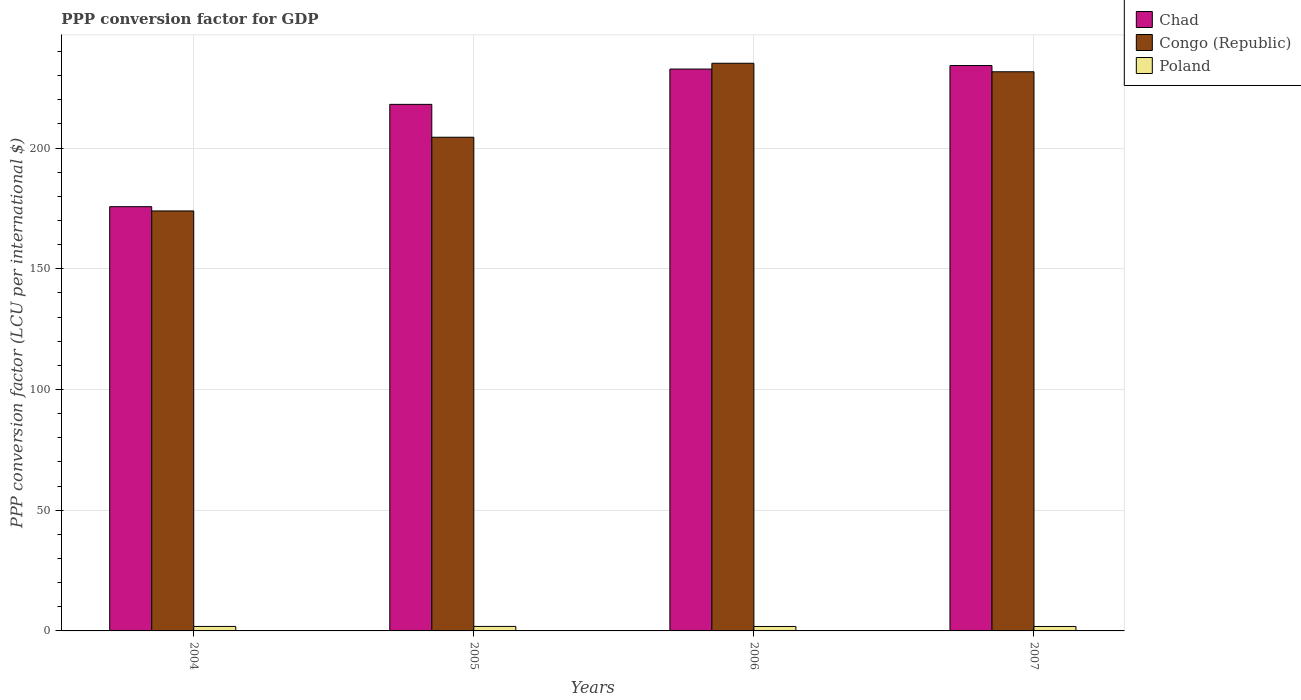How many different coloured bars are there?
Your answer should be compact. 3. How many bars are there on the 3rd tick from the right?
Give a very brief answer. 3. What is the label of the 4th group of bars from the left?
Provide a short and direct response. 2007. In how many cases, is the number of bars for a given year not equal to the number of legend labels?
Your answer should be compact. 0. What is the PPP conversion factor for GDP in Poland in 2006?
Keep it short and to the point. 1.84. Across all years, what is the maximum PPP conversion factor for GDP in Congo (Republic)?
Your response must be concise. 235.12. Across all years, what is the minimum PPP conversion factor for GDP in Poland?
Provide a short and direct response. 1.84. In which year was the PPP conversion factor for GDP in Poland maximum?
Give a very brief answer. 2005. In which year was the PPP conversion factor for GDP in Chad minimum?
Offer a very short reply. 2004. What is the total PPP conversion factor for GDP in Poland in the graph?
Make the answer very short. 7.42. What is the difference between the PPP conversion factor for GDP in Poland in 2004 and that in 2005?
Provide a short and direct response. -0.01. What is the difference between the PPP conversion factor for GDP in Chad in 2005 and the PPP conversion factor for GDP in Congo (Republic) in 2004?
Make the answer very short. 44.14. What is the average PPP conversion factor for GDP in Congo (Republic) per year?
Offer a terse response. 211.28. In the year 2004, what is the difference between the PPP conversion factor for GDP in Chad and PPP conversion factor for GDP in Congo (Republic)?
Ensure brevity in your answer.  1.76. What is the ratio of the PPP conversion factor for GDP in Poland in 2005 to that in 2007?
Offer a very short reply. 1.01. Is the PPP conversion factor for GDP in Poland in 2004 less than that in 2005?
Provide a succinct answer. Yes. Is the difference between the PPP conversion factor for GDP in Chad in 2004 and 2006 greater than the difference between the PPP conversion factor for GDP in Congo (Republic) in 2004 and 2006?
Give a very brief answer. Yes. What is the difference between the highest and the second highest PPP conversion factor for GDP in Chad?
Your response must be concise. 1.45. What is the difference between the highest and the lowest PPP conversion factor for GDP in Congo (Republic)?
Offer a very short reply. 61.17. Is the sum of the PPP conversion factor for GDP in Congo (Republic) in 2006 and 2007 greater than the maximum PPP conversion factor for GDP in Chad across all years?
Your response must be concise. Yes. What does the 1st bar from the left in 2007 represents?
Give a very brief answer. Chad. What does the 1st bar from the right in 2007 represents?
Ensure brevity in your answer.  Poland. Is it the case that in every year, the sum of the PPP conversion factor for GDP in Poland and PPP conversion factor for GDP in Congo (Republic) is greater than the PPP conversion factor for GDP in Chad?
Offer a terse response. No. What is the difference between two consecutive major ticks on the Y-axis?
Offer a very short reply. 50. Does the graph contain any zero values?
Make the answer very short. No. What is the title of the graph?
Offer a very short reply. PPP conversion factor for GDP. What is the label or title of the X-axis?
Ensure brevity in your answer.  Years. What is the label or title of the Y-axis?
Provide a succinct answer. PPP conversion factor (LCU per international $). What is the PPP conversion factor (LCU per international $) of Chad in 2004?
Provide a short and direct response. 175.71. What is the PPP conversion factor (LCU per international $) in Congo (Republic) in 2004?
Provide a short and direct response. 173.95. What is the PPP conversion factor (LCU per international $) of Poland in 2004?
Offer a terse response. 1.86. What is the PPP conversion factor (LCU per international $) in Chad in 2005?
Keep it short and to the point. 218.09. What is the PPP conversion factor (LCU per international $) of Congo (Republic) in 2005?
Provide a succinct answer. 204.47. What is the PPP conversion factor (LCU per international $) in Poland in 2005?
Offer a terse response. 1.87. What is the PPP conversion factor (LCU per international $) in Chad in 2006?
Provide a succinct answer. 232.72. What is the PPP conversion factor (LCU per international $) in Congo (Republic) in 2006?
Provide a short and direct response. 235.12. What is the PPP conversion factor (LCU per international $) in Poland in 2006?
Your answer should be compact. 1.84. What is the PPP conversion factor (LCU per international $) of Chad in 2007?
Provide a short and direct response. 234.17. What is the PPP conversion factor (LCU per international $) in Congo (Republic) in 2007?
Keep it short and to the point. 231.59. What is the PPP conversion factor (LCU per international $) of Poland in 2007?
Provide a short and direct response. 1.84. Across all years, what is the maximum PPP conversion factor (LCU per international $) in Chad?
Ensure brevity in your answer.  234.17. Across all years, what is the maximum PPP conversion factor (LCU per international $) in Congo (Republic)?
Your answer should be very brief. 235.12. Across all years, what is the maximum PPP conversion factor (LCU per international $) in Poland?
Provide a short and direct response. 1.87. Across all years, what is the minimum PPP conversion factor (LCU per international $) of Chad?
Keep it short and to the point. 175.71. Across all years, what is the minimum PPP conversion factor (LCU per international $) in Congo (Republic)?
Make the answer very short. 173.95. Across all years, what is the minimum PPP conversion factor (LCU per international $) in Poland?
Provide a short and direct response. 1.84. What is the total PPP conversion factor (LCU per international $) in Chad in the graph?
Your response must be concise. 860.69. What is the total PPP conversion factor (LCU per international $) in Congo (Republic) in the graph?
Your answer should be very brief. 845.13. What is the total PPP conversion factor (LCU per international $) in Poland in the graph?
Ensure brevity in your answer.  7.42. What is the difference between the PPP conversion factor (LCU per international $) in Chad in 2004 and that in 2005?
Provide a short and direct response. -42.38. What is the difference between the PPP conversion factor (LCU per international $) in Congo (Republic) in 2004 and that in 2005?
Make the answer very short. -30.52. What is the difference between the PPP conversion factor (LCU per international $) in Poland in 2004 and that in 2005?
Give a very brief answer. -0.01. What is the difference between the PPP conversion factor (LCU per international $) in Chad in 2004 and that in 2006?
Offer a terse response. -57. What is the difference between the PPP conversion factor (LCU per international $) in Congo (Republic) in 2004 and that in 2006?
Ensure brevity in your answer.  -61.17. What is the difference between the PPP conversion factor (LCU per international $) of Poland in 2004 and that in 2006?
Offer a very short reply. 0.02. What is the difference between the PPP conversion factor (LCU per international $) of Chad in 2004 and that in 2007?
Give a very brief answer. -58.46. What is the difference between the PPP conversion factor (LCU per international $) in Congo (Republic) in 2004 and that in 2007?
Give a very brief answer. -57.64. What is the difference between the PPP conversion factor (LCU per international $) in Poland in 2004 and that in 2007?
Make the answer very short. 0.02. What is the difference between the PPP conversion factor (LCU per international $) of Chad in 2005 and that in 2006?
Your answer should be very brief. -14.63. What is the difference between the PPP conversion factor (LCU per international $) in Congo (Republic) in 2005 and that in 2006?
Ensure brevity in your answer.  -30.64. What is the difference between the PPP conversion factor (LCU per international $) in Poland in 2005 and that in 2006?
Give a very brief answer. 0.03. What is the difference between the PPP conversion factor (LCU per international $) in Chad in 2005 and that in 2007?
Ensure brevity in your answer.  -16.08. What is the difference between the PPP conversion factor (LCU per international $) in Congo (Republic) in 2005 and that in 2007?
Provide a short and direct response. -27.12. What is the difference between the PPP conversion factor (LCU per international $) in Poland in 2005 and that in 2007?
Keep it short and to the point. 0.03. What is the difference between the PPP conversion factor (LCU per international $) in Chad in 2006 and that in 2007?
Give a very brief answer. -1.45. What is the difference between the PPP conversion factor (LCU per international $) of Congo (Republic) in 2006 and that in 2007?
Your answer should be very brief. 3.52. What is the difference between the PPP conversion factor (LCU per international $) of Poland in 2006 and that in 2007?
Give a very brief answer. 0. What is the difference between the PPP conversion factor (LCU per international $) in Chad in 2004 and the PPP conversion factor (LCU per international $) in Congo (Republic) in 2005?
Make the answer very short. -28.76. What is the difference between the PPP conversion factor (LCU per international $) in Chad in 2004 and the PPP conversion factor (LCU per international $) in Poland in 2005?
Keep it short and to the point. 173.84. What is the difference between the PPP conversion factor (LCU per international $) of Congo (Republic) in 2004 and the PPP conversion factor (LCU per international $) of Poland in 2005?
Provide a succinct answer. 172.08. What is the difference between the PPP conversion factor (LCU per international $) of Chad in 2004 and the PPP conversion factor (LCU per international $) of Congo (Republic) in 2006?
Offer a very short reply. -59.4. What is the difference between the PPP conversion factor (LCU per international $) in Chad in 2004 and the PPP conversion factor (LCU per international $) in Poland in 2006?
Your response must be concise. 173.87. What is the difference between the PPP conversion factor (LCU per international $) in Congo (Republic) in 2004 and the PPP conversion factor (LCU per international $) in Poland in 2006?
Ensure brevity in your answer.  172.11. What is the difference between the PPP conversion factor (LCU per international $) in Chad in 2004 and the PPP conversion factor (LCU per international $) in Congo (Republic) in 2007?
Provide a succinct answer. -55.88. What is the difference between the PPP conversion factor (LCU per international $) of Chad in 2004 and the PPP conversion factor (LCU per international $) of Poland in 2007?
Your response must be concise. 173.87. What is the difference between the PPP conversion factor (LCU per international $) in Congo (Republic) in 2004 and the PPP conversion factor (LCU per international $) in Poland in 2007?
Give a very brief answer. 172.11. What is the difference between the PPP conversion factor (LCU per international $) in Chad in 2005 and the PPP conversion factor (LCU per international $) in Congo (Republic) in 2006?
Provide a succinct answer. -17.02. What is the difference between the PPP conversion factor (LCU per international $) of Chad in 2005 and the PPP conversion factor (LCU per international $) of Poland in 2006?
Give a very brief answer. 216.25. What is the difference between the PPP conversion factor (LCU per international $) of Congo (Republic) in 2005 and the PPP conversion factor (LCU per international $) of Poland in 2006?
Keep it short and to the point. 202.63. What is the difference between the PPP conversion factor (LCU per international $) in Chad in 2005 and the PPP conversion factor (LCU per international $) in Congo (Republic) in 2007?
Your answer should be very brief. -13.5. What is the difference between the PPP conversion factor (LCU per international $) of Chad in 2005 and the PPP conversion factor (LCU per international $) of Poland in 2007?
Your answer should be compact. 216.25. What is the difference between the PPP conversion factor (LCU per international $) of Congo (Republic) in 2005 and the PPP conversion factor (LCU per international $) of Poland in 2007?
Offer a very short reply. 202.63. What is the difference between the PPP conversion factor (LCU per international $) of Chad in 2006 and the PPP conversion factor (LCU per international $) of Congo (Republic) in 2007?
Your response must be concise. 1.13. What is the difference between the PPP conversion factor (LCU per international $) in Chad in 2006 and the PPP conversion factor (LCU per international $) in Poland in 2007?
Provide a short and direct response. 230.87. What is the difference between the PPP conversion factor (LCU per international $) of Congo (Republic) in 2006 and the PPP conversion factor (LCU per international $) of Poland in 2007?
Give a very brief answer. 233.27. What is the average PPP conversion factor (LCU per international $) in Chad per year?
Your answer should be compact. 215.17. What is the average PPP conversion factor (LCU per international $) in Congo (Republic) per year?
Your answer should be very brief. 211.28. What is the average PPP conversion factor (LCU per international $) in Poland per year?
Your answer should be compact. 1.85. In the year 2004, what is the difference between the PPP conversion factor (LCU per international $) in Chad and PPP conversion factor (LCU per international $) in Congo (Republic)?
Offer a very short reply. 1.76. In the year 2004, what is the difference between the PPP conversion factor (LCU per international $) in Chad and PPP conversion factor (LCU per international $) in Poland?
Your response must be concise. 173.85. In the year 2004, what is the difference between the PPP conversion factor (LCU per international $) of Congo (Republic) and PPP conversion factor (LCU per international $) of Poland?
Provide a short and direct response. 172.09. In the year 2005, what is the difference between the PPP conversion factor (LCU per international $) of Chad and PPP conversion factor (LCU per international $) of Congo (Republic)?
Offer a terse response. 13.62. In the year 2005, what is the difference between the PPP conversion factor (LCU per international $) in Chad and PPP conversion factor (LCU per international $) in Poland?
Offer a very short reply. 216.22. In the year 2005, what is the difference between the PPP conversion factor (LCU per international $) in Congo (Republic) and PPP conversion factor (LCU per international $) in Poland?
Provide a short and direct response. 202.6. In the year 2006, what is the difference between the PPP conversion factor (LCU per international $) of Chad and PPP conversion factor (LCU per international $) of Congo (Republic)?
Your answer should be very brief. -2.4. In the year 2006, what is the difference between the PPP conversion factor (LCU per international $) of Chad and PPP conversion factor (LCU per international $) of Poland?
Make the answer very short. 230.87. In the year 2006, what is the difference between the PPP conversion factor (LCU per international $) in Congo (Republic) and PPP conversion factor (LCU per international $) in Poland?
Provide a short and direct response. 233.27. In the year 2007, what is the difference between the PPP conversion factor (LCU per international $) in Chad and PPP conversion factor (LCU per international $) in Congo (Republic)?
Your answer should be very brief. 2.58. In the year 2007, what is the difference between the PPP conversion factor (LCU per international $) in Chad and PPP conversion factor (LCU per international $) in Poland?
Offer a terse response. 232.33. In the year 2007, what is the difference between the PPP conversion factor (LCU per international $) of Congo (Republic) and PPP conversion factor (LCU per international $) of Poland?
Your answer should be compact. 229.75. What is the ratio of the PPP conversion factor (LCU per international $) of Chad in 2004 to that in 2005?
Give a very brief answer. 0.81. What is the ratio of the PPP conversion factor (LCU per international $) in Congo (Republic) in 2004 to that in 2005?
Provide a succinct answer. 0.85. What is the ratio of the PPP conversion factor (LCU per international $) of Chad in 2004 to that in 2006?
Your answer should be compact. 0.76. What is the ratio of the PPP conversion factor (LCU per international $) in Congo (Republic) in 2004 to that in 2006?
Provide a succinct answer. 0.74. What is the ratio of the PPP conversion factor (LCU per international $) in Poland in 2004 to that in 2006?
Offer a terse response. 1.01. What is the ratio of the PPP conversion factor (LCU per international $) of Chad in 2004 to that in 2007?
Your response must be concise. 0.75. What is the ratio of the PPP conversion factor (LCU per international $) in Congo (Republic) in 2004 to that in 2007?
Offer a very short reply. 0.75. What is the ratio of the PPP conversion factor (LCU per international $) in Poland in 2004 to that in 2007?
Keep it short and to the point. 1.01. What is the ratio of the PPP conversion factor (LCU per international $) in Chad in 2005 to that in 2006?
Provide a succinct answer. 0.94. What is the ratio of the PPP conversion factor (LCU per international $) of Congo (Republic) in 2005 to that in 2006?
Give a very brief answer. 0.87. What is the ratio of the PPP conversion factor (LCU per international $) of Poland in 2005 to that in 2006?
Your answer should be compact. 1.01. What is the ratio of the PPP conversion factor (LCU per international $) of Chad in 2005 to that in 2007?
Keep it short and to the point. 0.93. What is the ratio of the PPP conversion factor (LCU per international $) in Congo (Republic) in 2005 to that in 2007?
Keep it short and to the point. 0.88. What is the ratio of the PPP conversion factor (LCU per international $) of Poland in 2005 to that in 2007?
Your response must be concise. 1.01. What is the ratio of the PPP conversion factor (LCU per international $) in Congo (Republic) in 2006 to that in 2007?
Ensure brevity in your answer.  1.02. What is the ratio of the PPP conversion factor (LCU per international $) in Poland in 2006 to that in 2007?
Offer a terse response. 1. What is the difference between the highest and the second highest PPP conversion factor (LCU per international $) of Chad?
Your answer should be compact. 1.45. What is the difference between the highest and the second highest PPP conversion factor (LCU per international $) of Congo (Republic)?
Make the answer very short. 3.52. What is the difference between the highest and the second highest PPP conversion factor (LCU per international $) in Poland?
Offer a very short reply. 0.01. What is the difference between the highest and the lowest PPP conversion factor (LCU per international $) in Chad?
Make the answer very short. 58.46. What is the difference between the highest and the lowest PPP conversion factor (LCU per international $) in Congo (Republic)?
Provide a short and direct response. 61.17. What is the difference between the highest and the lowest PPP conversion factor (LCU per international $) in Poland?
Provide a short and direct response. 0.03. 